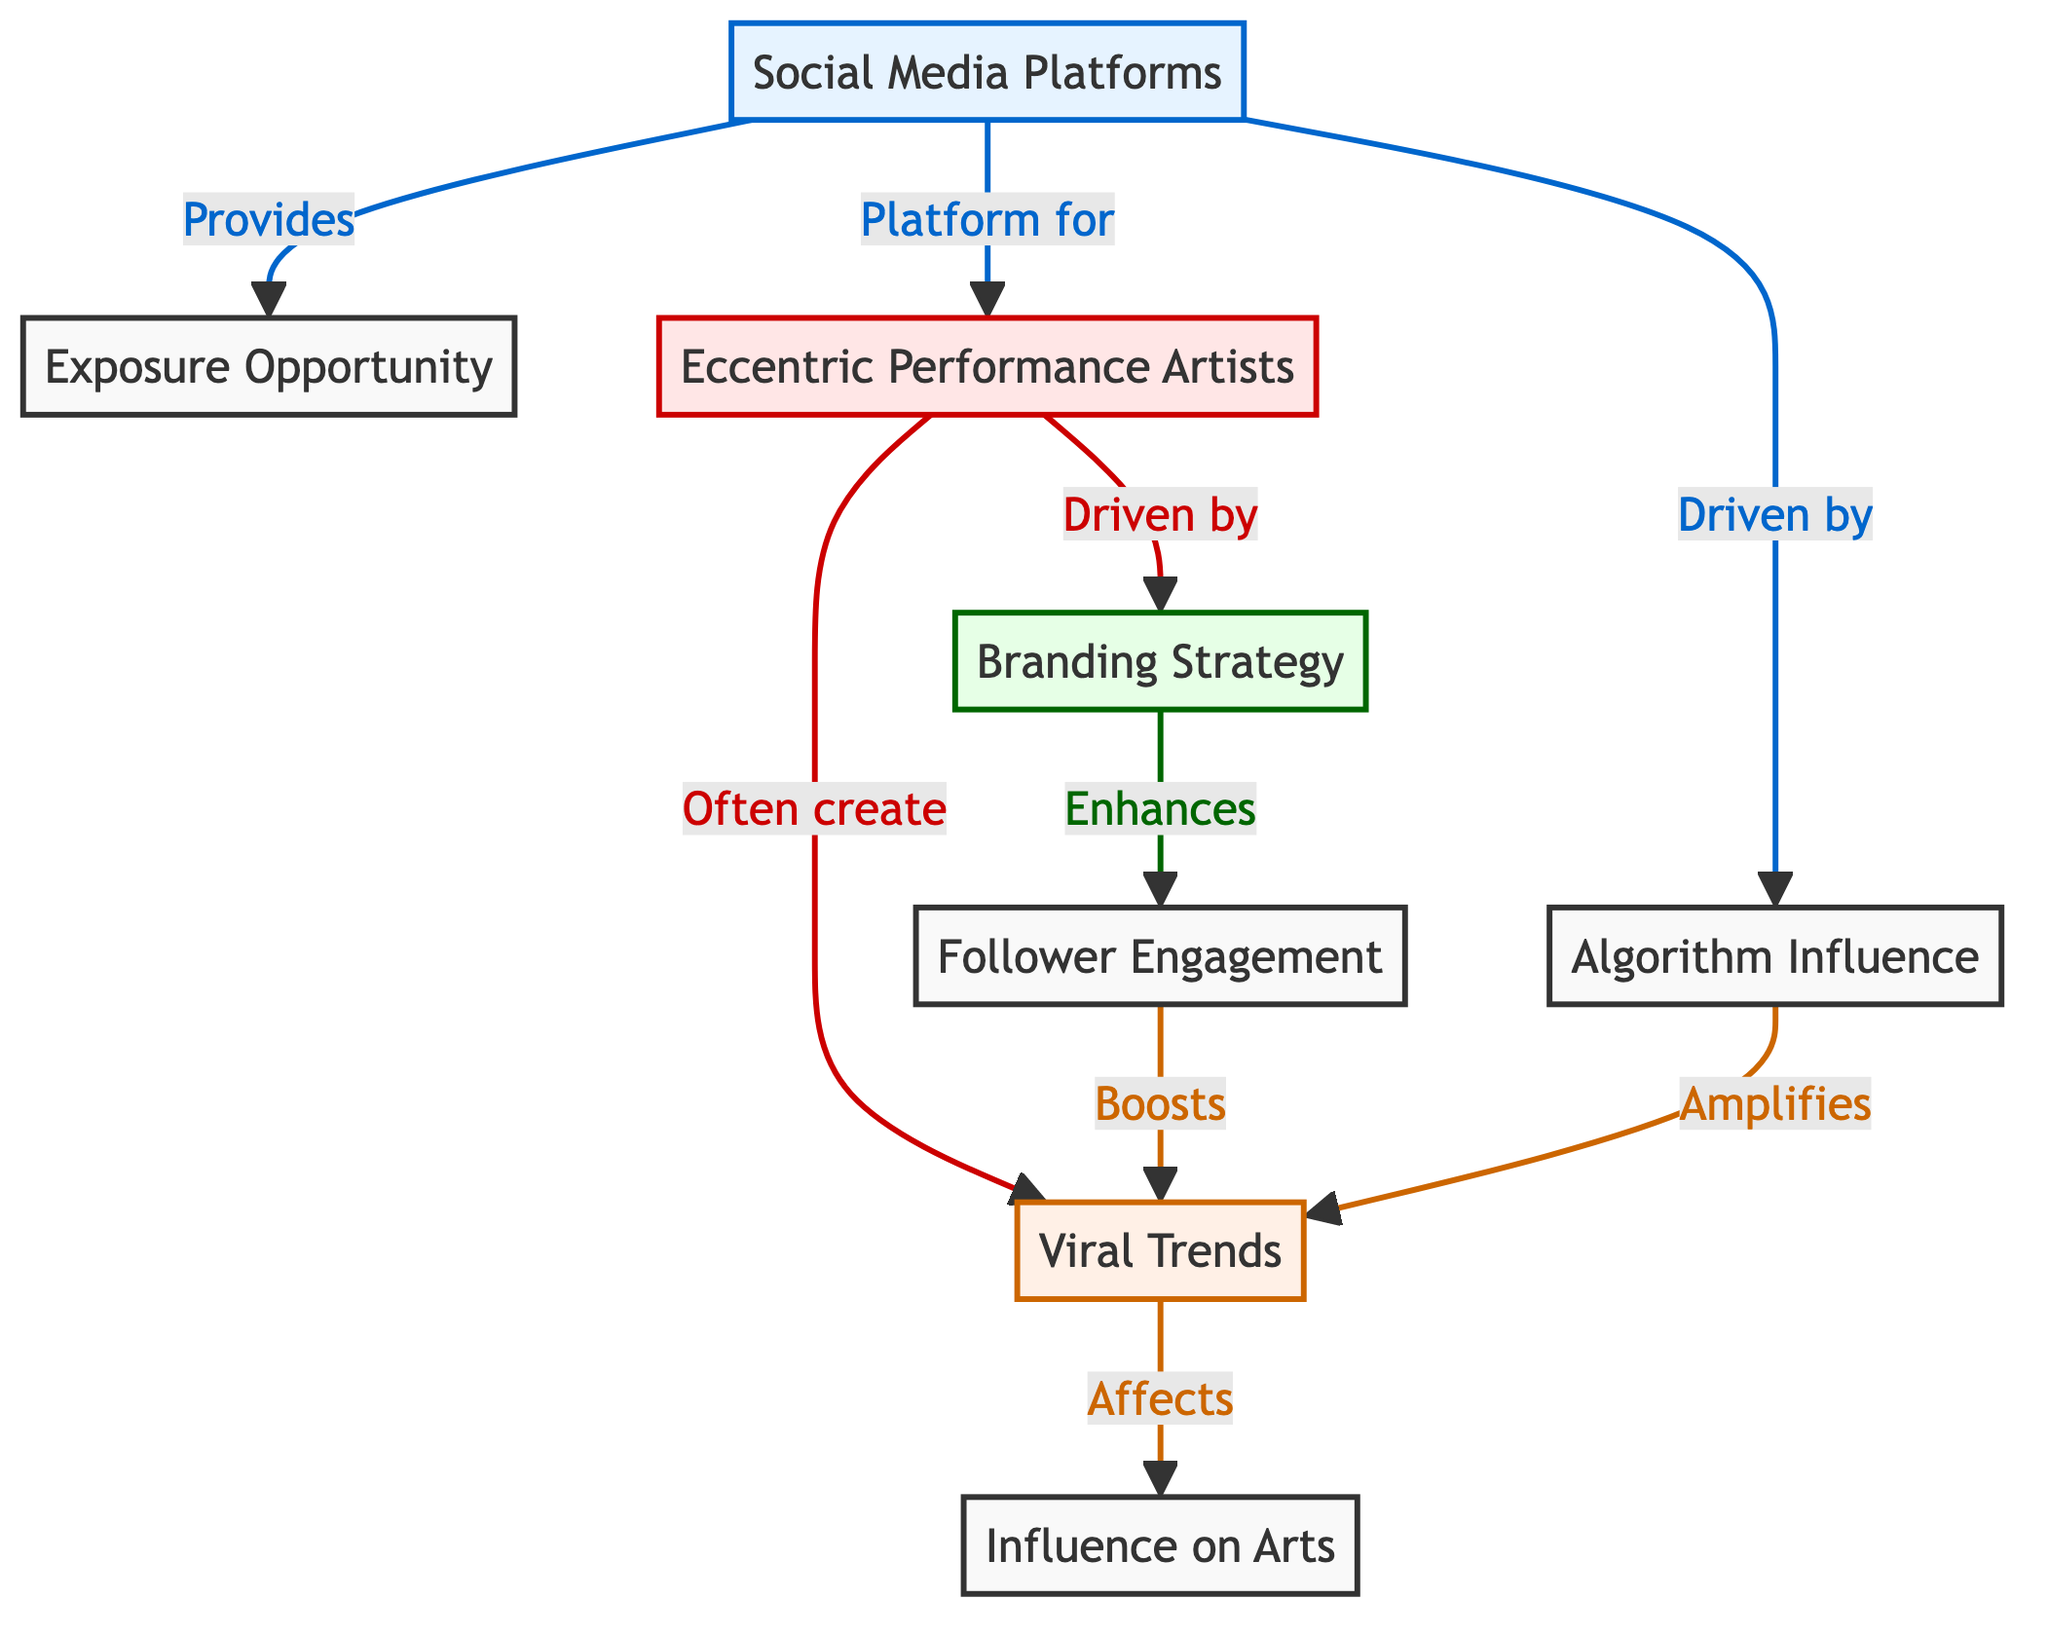What role do social media platforms play in relation to exposure opportunities? The diagram indicates that social media platforms provide exposure opportunities for artists. This is shown through the directed edge labeled “Provides” from the Social Media Platforms node to the Exposure Opportunity node.
Answer: Provides How many nodes represent the strategies related to eccentric performance artists? The diagram includes only one node that represents a strategy related to eccentric performance artists, which is the Branding Strategy node. There are no multiple strategy nodes depicted.
Answer: One What is the relationship between follower engagement and viral trends? The diagram shows that follower engagement enhances viral trends. This can be traced through the directed edge labeled “Enhances” from the Branding Strategy node to the Follower Engagement node, followed by another edge labeled “Boosts” from Follower Engagement to Viral Trends.
Answer: Enhances Which artist category is affected by viral trends? The diagram shows that viral trends affect the Influence on Arts category, implying that the effects of trends ultimately reach how they influence artistic expressions. This relationship is indicated by the directed edge from the Viral Trends node to the Influence on Arts node.
Answer: Influence on Arts What is the influence of algorithms on viral trends? The directed edge labeled “Amplifies” connects the Algorithm Influence node to the Viral Trends node, indicating that algorithms have a positive incrementing effect on how trends spread virally. Therefore, algorithms play a role in enhancing the reach of trends.
Answer: Amplifies How do eccentric performance artists create trends according to this diagram? Eccentric performance artists often create viral trends, as shown by the directed edge labeled “Often create” from the Eccentric Performance Artists node to the Viral Trends node in the diagram. This indicates a direct creative role of these artists in generating trends.
Answer: Often create What does the social media platform influence regarding artists? The diagram indicates that social media platforms serve as a platform for eccentric performance artists. This is illustrated by the directed edge labeled “Platform for” connecting the Social Media Platforms node to the Eccentric Performance Artists node. Thus, they promote the performance artists directly.
Answer: Platform for What is indicated as a strategy that influences how artists engage with their followers? The diagram identifies Branding Strategy as a strategy that enhances follower engagement. This is indicated by the directed edge from the Branding Strategy node to the Follower Engagement node, meaning that the branding approach is key to improving engagement.
Answer: Branding Strategy 